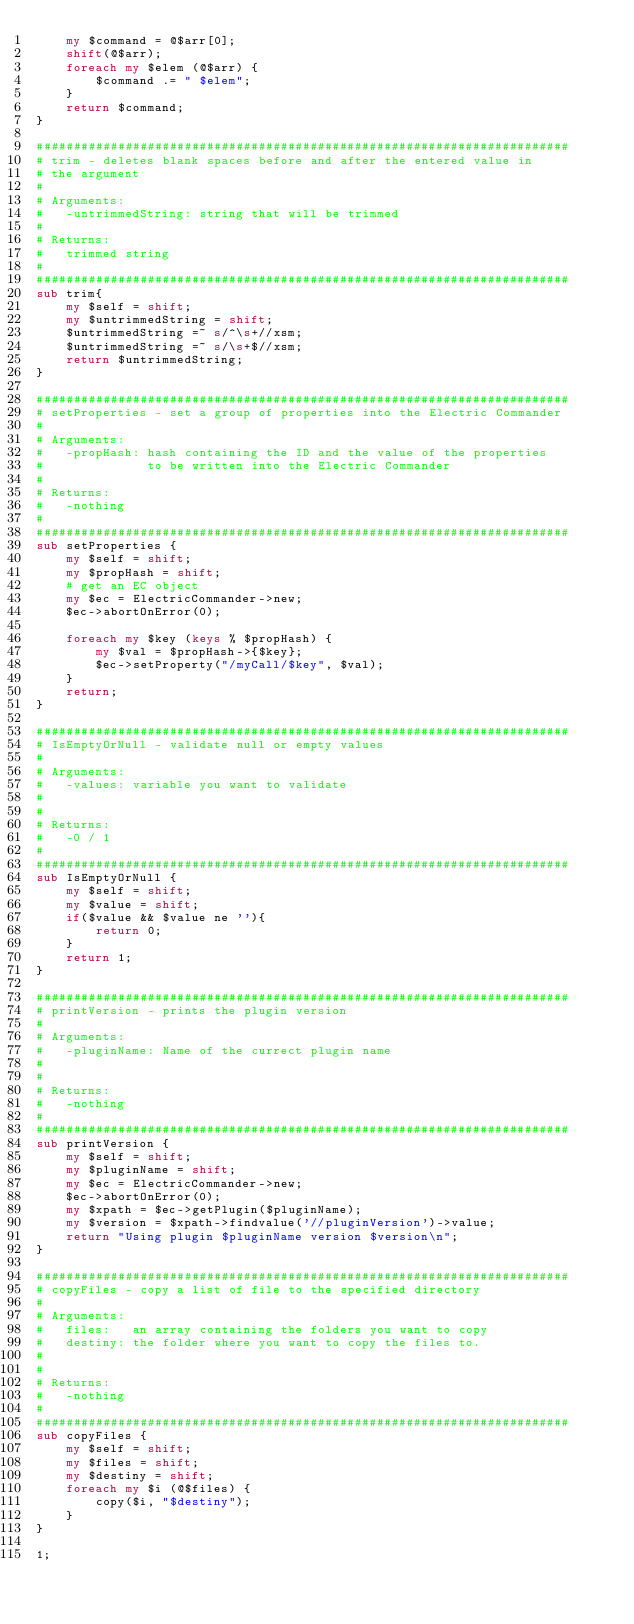Convert code to text. <code><loc_0><loc_0><loc_500><loc_500><_Perl_>    my $command = @$arr[0];
    shift(@$arr);
    foreach my $elem (@$arr) {
        $command .= " $elem";
    }
    return $command;
}

########################################################################
# trim - deletes blank spaces before and after the entered value in
# the argument
#
# Arguments:
#   -untrimmedString: string that will be trimmed
#
# Returns:
#   trimmed string
#
########################################################################
sub trim{
    my $self = shift;
    my $untrimmedString = shift;
    $untrimmedString =~ s/^\s+//xsm;
    $untrimmedString =~ s/\s+$//xsm;
    return $untrimmedString;
}

########################################################################
# setProperties - set a group of properties into the Electric Commander
#
# Arguments:
#   -propHash: hash containing the ID and the value of the properties
#              to be written into the Electric Commander
#
# Returns:
#   -nothing
#
########################################################################
sub setProperties {
    my $self = shift;
    my $propHash = shift;
    # get an EC object
    my $ec = ElectricCommander->new;
    $ec->abortOnError(0);

    foreach my $key (keys % $propHash) {
        my $val = $propHash->{$key};
        $ec->setProperty("/myCall/$key", $val);
    }
    return;
}

########################################################################
# IsEmptyOrNull - validate null or empty values
#
# Arguments:
#   -values: variable you want to validate
#
#
# Returns:
#   -0 / 1 
#
########################################################################
sub IsEmptyOrNull {
    my $self = shift;
    my $value = shift;
    if($value && $value ne ''){
        return 0;
    }
    return 1;
}

########################################################################
# printVersion - prints the plugin version
#
# Arguments:
#   -pluginName: Name of the currect plugin name
#
#
# Returns:
#   -nothing
#
########################################################################
sub printVersion {
    my $self = shift;
    my $pluginName = shift;
    my $ec = ElectricCommander->new;
    $ec->abortOnError(0);
    my $xpath = $ec->getPlugin($pluginName);
    my $version = $xpath->findvalue('//pluginVersion')->value;
    return "Using plugin $pluginName version $version\n";
}

########################################################################
# copyFiles - copy a list of file to the specified directory
#
# Arguments:
#   files:   an array containing the folders you want to copy
#   destiny: the folder where you want to copy the files to.
#
#
# Returns:
#   -nothing
#
########################################################################
sub copyFiles {
    my $self = shift;
    my $files = shift;
    my $destiny = shift;
    foreach my $i (@$files) {
        copy($i, "$destiny");
    }
}

1;
</code> 